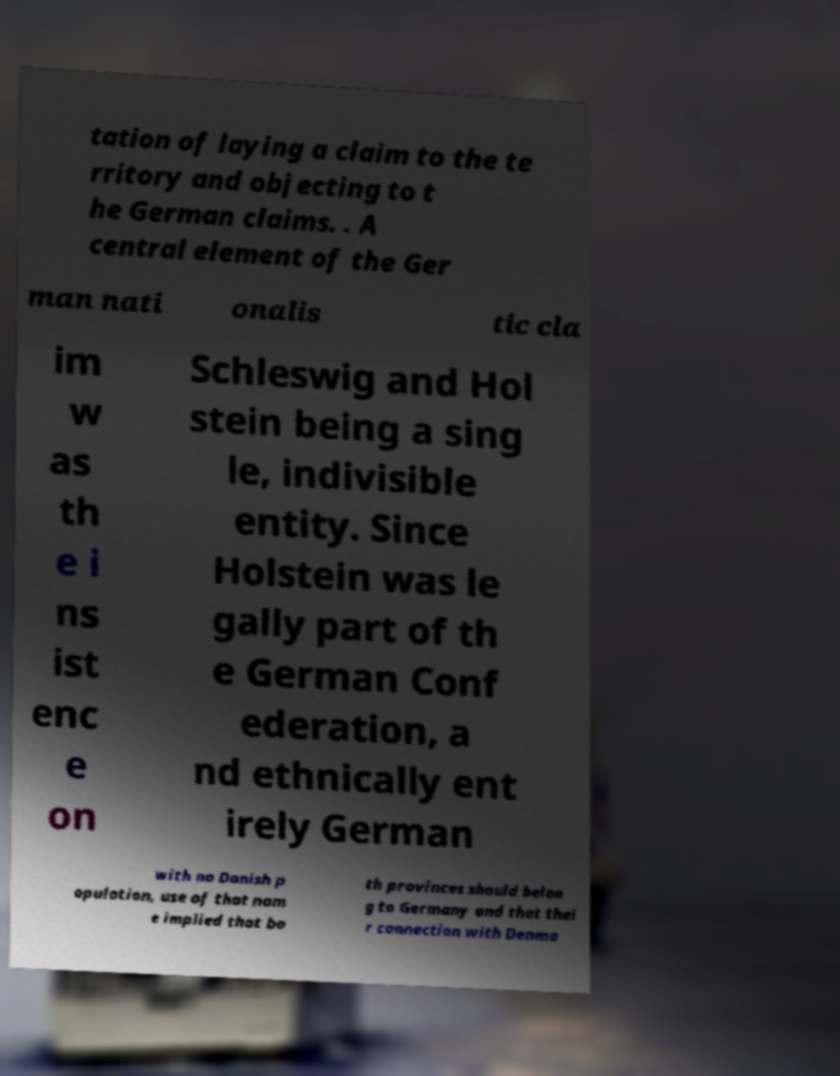What messages or text are displayed in this image? I need them in a readable, typed format. tation of laying a claim to the te rritory and objecting to t he German claims. . A central element of the Ger man nati onalis tic cla im w as th e i ns ist enc e on Schleswig and Hol stein being a sing le, indivisible entity. Since Holstein was le gally part of th e German Conf ederation, a nd ethnically ent irely German with no Danish p opulation, use of that nam e implied that bo th provinces should belon g to Germany and that thei r connection with Denma 